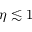<formula> <loc_0><loc_0><loc_500><loc_500>\eta \lesssim 1</formula> 